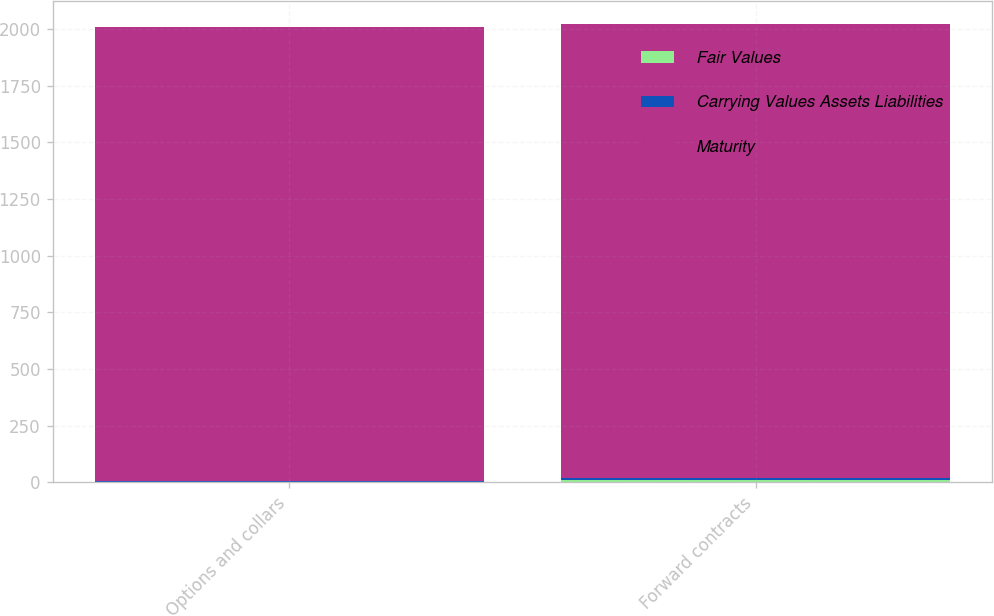Convert chart. <chart><loc_0><loc_0><loc_500><loc_500><stacked_bar_chart><ecel><fcel>Options and collars<fcel>Forward contracts<nl><fcel>Fair Values<fcel>3<fcel>10<nl><fcel>Carrying Values Assets Liabilities<fcel>3<fcel>10<nl><fcel>Maturity<fcel>2004<fcel>2003<nl></chart> 